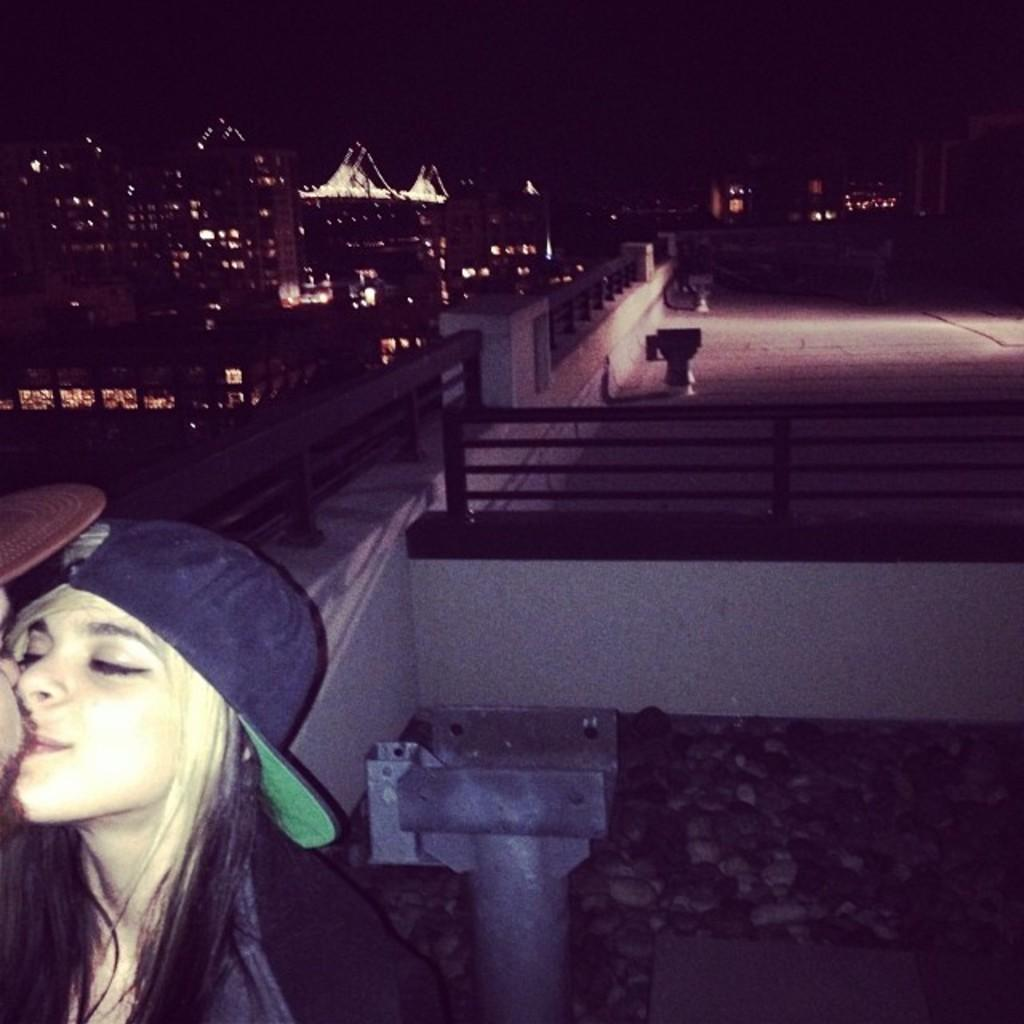What type of structures are visible in the image? There are buildings with lights in the image. What architectural feature can be seen on a wall in the image? There is railing on a wall in the image. What type of material is used for the rods in the image? There are metal rods in the image. How many people are visible on the left side of the image? There are two persons on the left side of the image. What type of writing can be seen on the railing in the image? There is no writing visible on the railing in the image. What is the profit margin of the buildings in the image? The image does not provide any information about the profit margin of the buildings. 